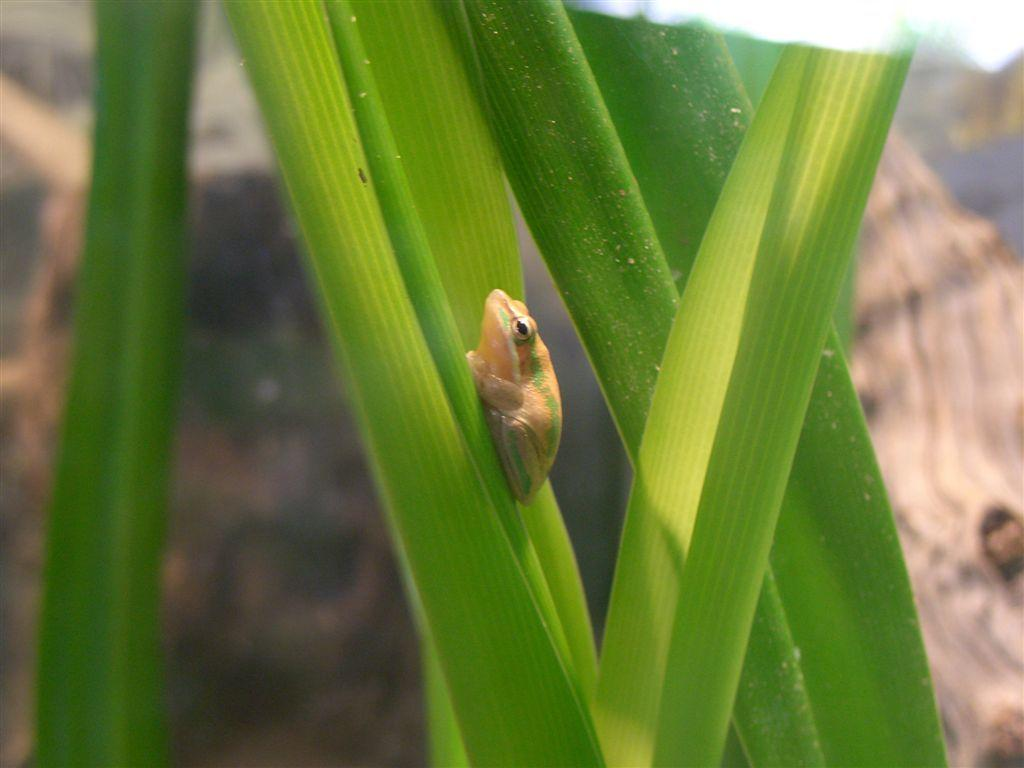Where was the image taken? The image is taken outdoors. How is the background of the image? The background is a little blurred. What is the main subject of the image? There is a frog in the middle of the image. What is the frog sitting on? The frog is on a green leaf. What type of vegetation can be seen in the image? There are green leaves in the image. Can you see any clouds in the image? There are no clouds visible in the image. Are there any students kissing in the image? There are no students or any kissing activity present in the image. 